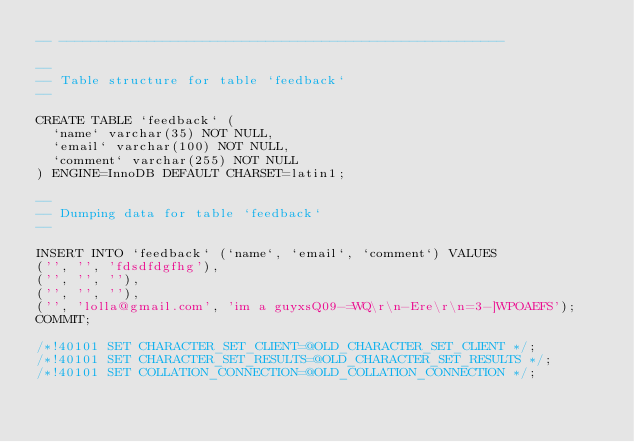<code> <loc_0><loc_0><loc_500><loc_500><_SQL_>-- --------------------------------------------------------

--
-- Table structure for table `feedback`
--

CREATE TABLE `feedback` (
  `name` varchar(35) NOT NULL,
  `email` varchar(100) NOT NULL,
  `comment` varchar(255) NOT NULL
) ENGINE=InnoDB DEFAULT CHARSET=latin1;

--
-- Dumping data for table `feedback`
--

INSERT INTO `feedback` (`name`, `email`, `comment`) VALUES
('', '', 'fdsdfdgfhg'),
('', '', ''),
('', '', ''),
('', 'lolla@gmail.com', 'im a guyxsQ09-=WQ\r\n-Ere\r\n=3-]WPOAEFS');
COMMIT;

/*!40101 SET CHARACTER_SET_CLIENT=@OLD_CHARACTER_SET_CLIENT */;
/*!40101 SET CHARACTER_SET_RESULTS=@OLD_CHARACTER_SET_RESULTS */;
/*!40101 SET COLLATION_CONNECTION=@OLD_COLLATION_CONNECTION */;
</code> 